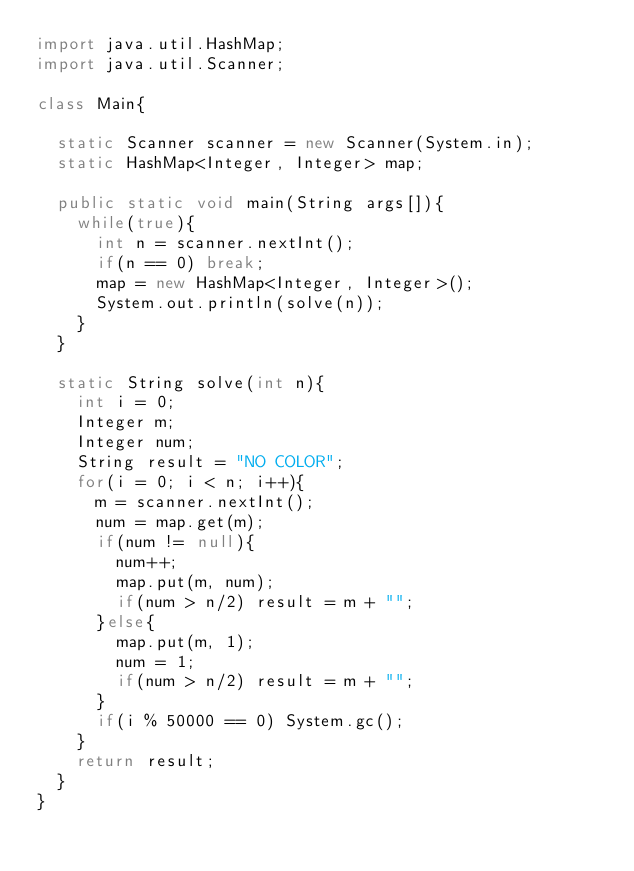<code> <loc_0><loc_0><loc_500><loc_500><_Java_>import java.util.HashMap;
import java.util.Scanner;

class Main{

	static Scanner scanner = new Scanner(System.in);
	static HashMap<Integer, Integer> map;

	public static void main(String args[]){
		while(true){
			int n = scanner.nextInt();
			if(n == 0) break;
			map = new HashMap<Integer, Integer>();
			System.out.println(solve(n));
		}
	}

	static String solve(int n){
		int i = 0;
		Integer m;
		Integer num;
		String result = "NO COLOR";
		for(i = 0; i < n; i++){
			m = scanner.nextInt();
			num = map.get(m);
			if(num != null){
				num++;
				map.put(m, num);
				if(num > n/2) result = m + "";
			}else{
				map.put(m, 1);
				num = 1;
				if(num > n/2) result = m + "";
			}
			if(i % 50000 == 0) System.gc();
		}
		return result;
	}
}</code> 